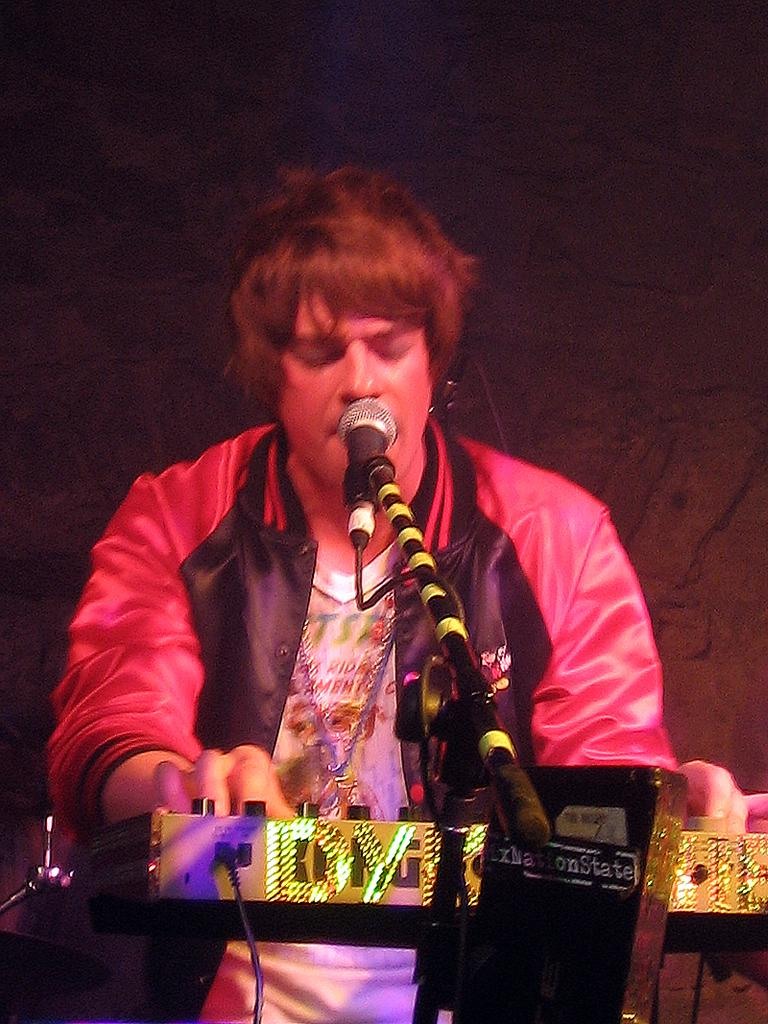What is the main subject of the image? The main subject of the image is a man. What is the man doing in the image? The man is standing in the image. What is the man holding in the image? The man is holding a musical instrument in the image. What object is placed on the floor in front of the man? There is a microphone placed on the floor in front of the man. What type of lace can be seen on the man's clothing in the image? There is no lace visible on the man's clothing in the image. Can you tell me how many tombstones are present in the cemetery in the image? There is no cemetery present in the image; it features a man standing with a musical instrument and a microphone. 